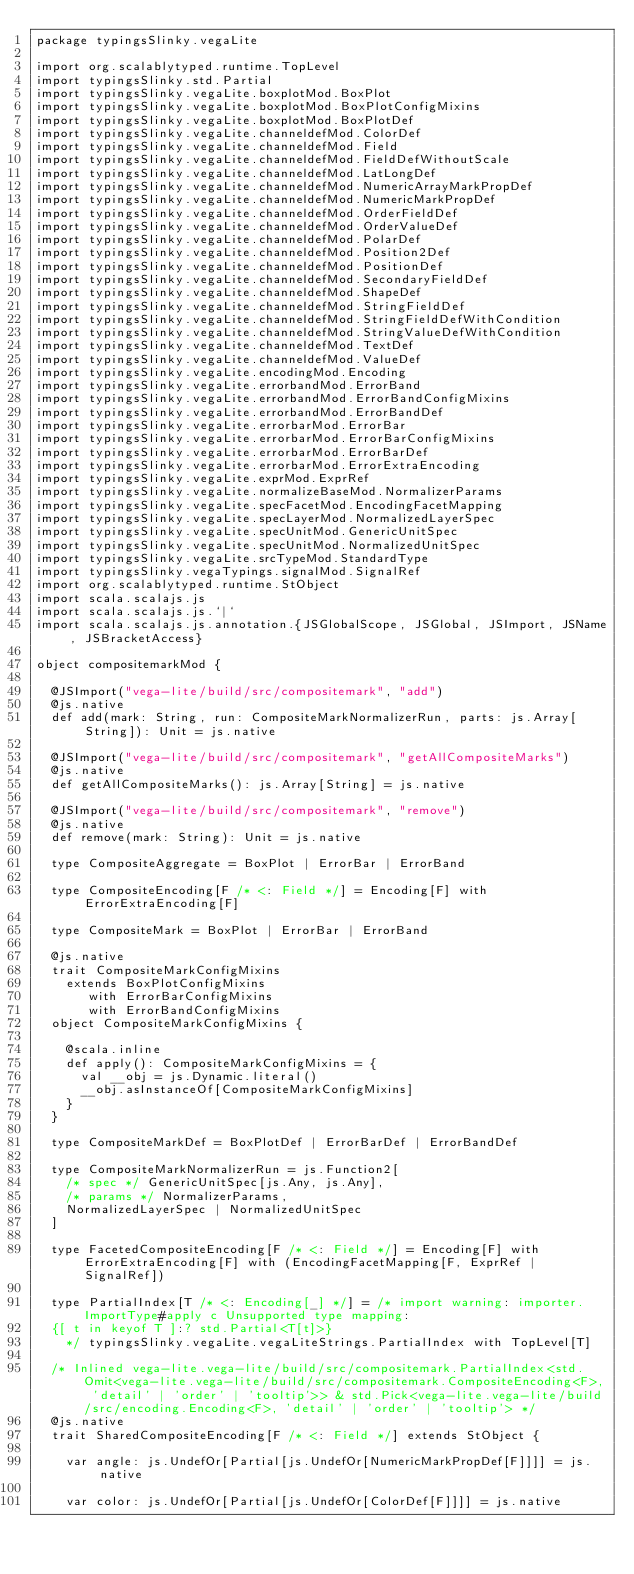Convert code to text. <code><loc_0><loc_0><loc_500><loc_500><_Scala_>package typingsSlinky.vegaLite

import org.scalablytyped.runtime.TopLevel
import typingsSlinky.std.Partial
import typingsSlinky.vegaLite.boxplotMod.BoxPlot
import typingsSlinky.vegaLite.boxplotMod.BoxPlotConfigMixins
import typingsSlinky.vegaLite.boxplotMod.BoxPlotDef
import typingsSlinky.vegaLite.channeldefMod.ColorDef
import typingsSlinky.vegaLite.channeldefMod.Field
import typingsSlinky.vegaLite.channeldefMod.FieldDefWithoutScale
import typingsSlinky.vegaLite.channeldefMod.LatLongDef
import typingsSlinky.vegaLite.channeldefMod.NumericArrayMarkPropDef
import typingsSlinky.vegaLite.channeldefMod.NumericMarkPropDef
import typingsSlinky.vegaLite.channeldefMod.OrderFieldDef
import typingsSlinky.vegaLite.channeldefMod.OrderValueDef
import typingsSlinky.vegaLite.channeldefMod.PolarDef
import typingsSlinky.vegaLite.channeldefMod.Position2Def
import typingsSlinky.vegaLite.channeldefMod.PositionDef
import typingsSlinky.vegaLite.channeldefMod.SecondaryFieldDef
import typingsSlinky.vegaLite.channeldefMod.ShapeDef
import typingsSlinky.vegaLite.channeldefMod.StringFieldDef
import typingsSlinky.vegaLite.channeldefMod.StringFieldDefWithCondition
import typingsSlinky.vegaLite.channeldefMod.StringValueDefWithCondition
import typingsSlinky.vegaLite.channeldefMod.TextDef
import typingsSlinky.vegaLite.channeldefMod.ValueDef
import typingsSlinky.vegaLite.encodingMod.Encoding
import typingsSlinky.vegaLite.errorbandMod.ErrorBand
import typingsSlinky.vegaLite.errorbandMod.ErrorBandConfigMixins
import typingsSlinky.vegaLite.errorbandMod.ErrorBandDef
import typingsSlinky.vegaLite.errorbarMod.ErrorBar
import typingsSlinky.vegaLite.errorbarMod.ErrorBarConfigMixins
import typingsSlinky.vegaLite.errorbarMod.ErrorBarDef
import typingsSlinky.vegaLite.errorbarMod.ErrorExtraEncoding
import typingsSlinky.vegaLite.exprMod.ExprRef
import typingsSlinky.vegaLite.normalizeBaseMod.NormalizerParams
import typingsSlinky.vegaLite.specFacetMod.EncodingFacetMapping
import typingsSlinky.vegaLite.specLayerMod.NormalizedLayerSpec
import typingsSlinky.vegaLite.specUnitMod.GenericUnitSpec
import typingsSlinky.vegaLite.specUnitMod.NormalizedUnitSpec
import typingsSlinky.vegaLite.srcTypeMod.StandardType
import typingsSlinky.vegaTypings.signalMod.SignalRef
import org.scalablytyped.runtime.StObject
import scala.scalajs.js
import scala.scalajs.js.`|`
import scala.scalajs.js.annotation.{JSGlobalScope, JSGlobal, JSImport, JSName, JSBracketAccess}

object compositemarkMod {
  
  @JSImport("vega-lite/build/src/compositemark", "add")
  @js.native
  def add(mark: String, run: CompositeMarkNormalizerRun, parts: js.Array[String]): Unit = js.native
  
  @JSImport("vega-lite/build/src/compositemark", "getAllCompositeMarks")
  @js.native
  def getAllCompositeMarks(): js.Array[String] = js.native
  
  @JSImport("vega-lite/build/src/compositemark", "remove")
  @js.native
  def remove(mark: String): Unit = js.native
  
  type CompositeAggregate = BoxPlot | ErrorBar | ErrorBand
  
  type CompositeEncoding[F /* <: Field */] = Encoding[F] with ErrorExtraEncoding[F]
  
  type CompositeMark = BoxPlot | ErrorBar | ErrorBand
  
  @js.native
  trait CompositeMarkConfigMixins
    extends BoxPlotConfigMixins
       with ErrorBarConfigMixins
       with ErrorBandConfigMixins
  object CompositeMarkConfigMixins {
    
    @scala.inline
    def apply(): CompositeMarkConfigMixins = {
      val __obj = js.Dynamic.literal()
      __obj.asInstanceOf[CompositeMarkConfigMixins]
    }
  }
  
  type CompositeMarkDef = BoxPlotDef | ErrorBarDef | ErrorBandDef
  
  type CompositeMarkNormalizerRun = js.Function2[
    /* spec */ GenericUnitSpec[js.Any, js.Any], 
    /* params */ NormalizerParams, 
    NormalizedLayerSpec | NormalizedUnitSpec
  ]
  
  type FacetedCompositeEncoding[F /* <: Field */] = Encoding[F] with ErrorExtraEncoding[F] with (EncodingFacetMapping[F, ExprRef | SignalRef])
  
  type PartialIndex[T /* <: Encoding[_] */] = /* import warning: importer.ImportType#apply c Unsupported type mapping: 
  {[ t in keyof T ]:? std.Partial<T[t]>}
    */ typingsSlinky.vegaLite.vegaLiteStrings.PartialIndex with TopLevel[T]
  
  /* Inlined vega-lite.vega-lite/build/src/compositemark.PartialIndex<std.Omit<vega-lite.vega-lite/build/src/compositemark.CompositeEncoding<F>, 'detail' | 'order' | 'tooltip'>> & std.Pick<vega-lite.vega-lite/build/src/encoding.Encoding<F>, 'detail' | 'order' | 'tooltip'> */
  @js.native
  trait SharedCompositeEncoding[F /* <: Field */] extends StObject {
    
    var angle: js.UndefOr[Partial[js.UndefOr[NumericMarkPropDef[F]]]] = js.native
    
    var color: js.UndefOr[Partial[js.UndefOr[ColorDef[F]]]] = js.native
    </code> 